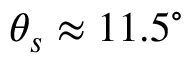Convert formula to latex. <formula><loc_0><loc_0><loc_500><loc_500>\theta _ { s } \approx 1 1 . 5 ^ { \circ }</formula> 